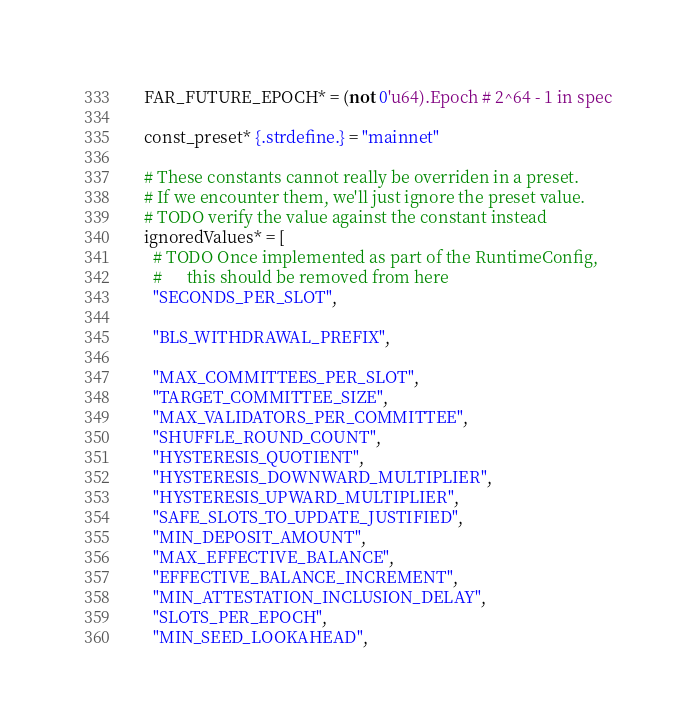<code> <loc_0><loc_0><loc_500><loc_500><_Nim_>  FAR_FUTURE_EPOCH* = (not 0'u64).Epoch # 2^64 - 1 in spec

  const_preset* {.strdefine.} = "mainnet"

  # These constants cannot really be overriden in a preset.
  # If we encounter them, we'll just ignore the preset value.
  # TODO verify the value against the constant instead
  ignoredValues* = [
    # TODO Once implemented as part of the RuntimeConfig,
    #      this should be removed from here
    "SECONDS_PER_SLOT",

    "BLS_WITHDRAWAL_PREFIX",

    "MAX_COMMITTEES_PER_SLOT",
    "TARGET_COMMITTEE_SIZE",
    "MAX_VALIDATORS_PER_COMMITTEE",
    "SHUFFLE_ROUND_COUNT",
    "HYSTERESIS_QUOTIENT",
    "HYSTERESIS_DOWNWARD_MULTIPLIER",
    "HYSTERESIS_UPWARD_MULTIPLIER",
    "SAFE_SLOTS_TO_UPDATE_JUSTIFIED",
    "MIN_DEPOSIT_AMOUNT",
    "MAX_EFFECTIVE_BALANCE",
    "EFFECTIVE_BALANCE_INCREMENT",
    "MIN_ATTESTATION_INCLUSION_DELAY",
    "SLOTS_PER_EPOCH",
    "MIN_SEED_LOOKAHEAD",</code> 